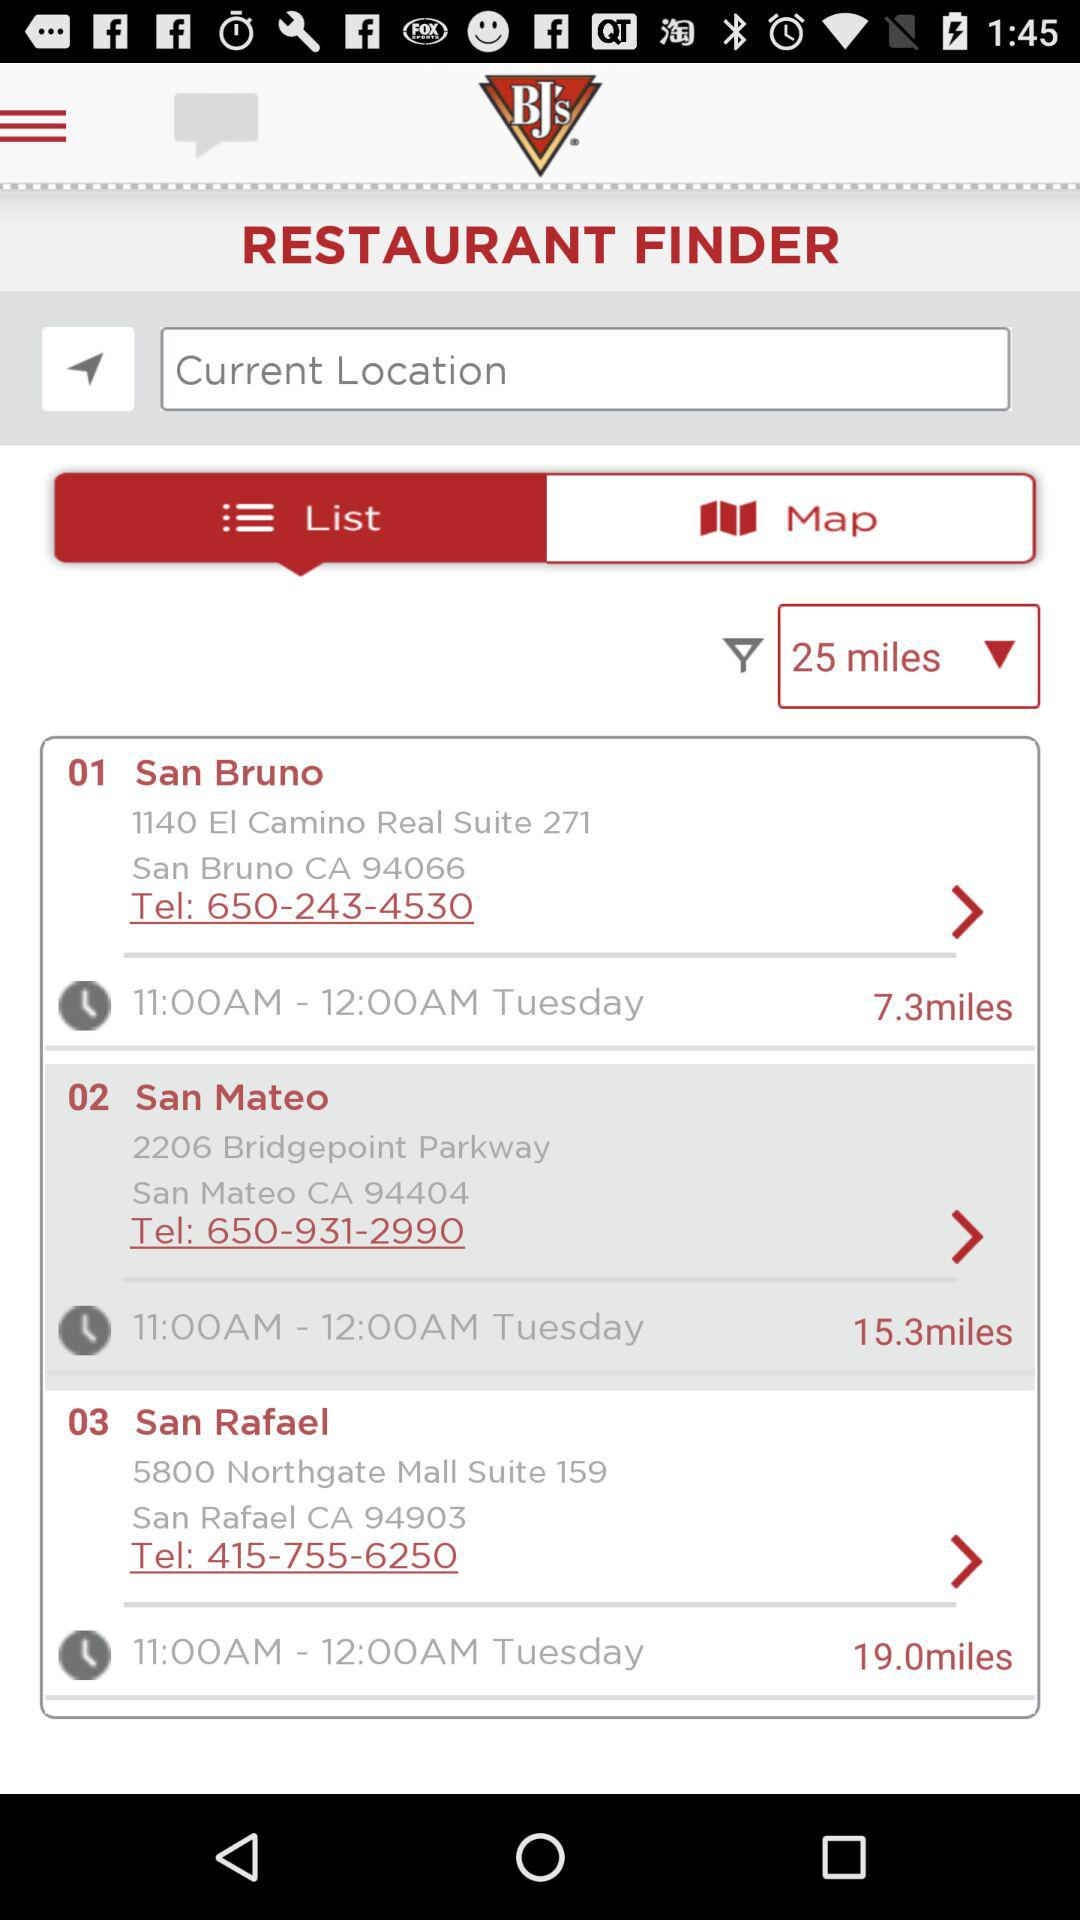How far is the "San Bruno" restaurant? The "San Bruno" restaurant is 7.3 miles away. 